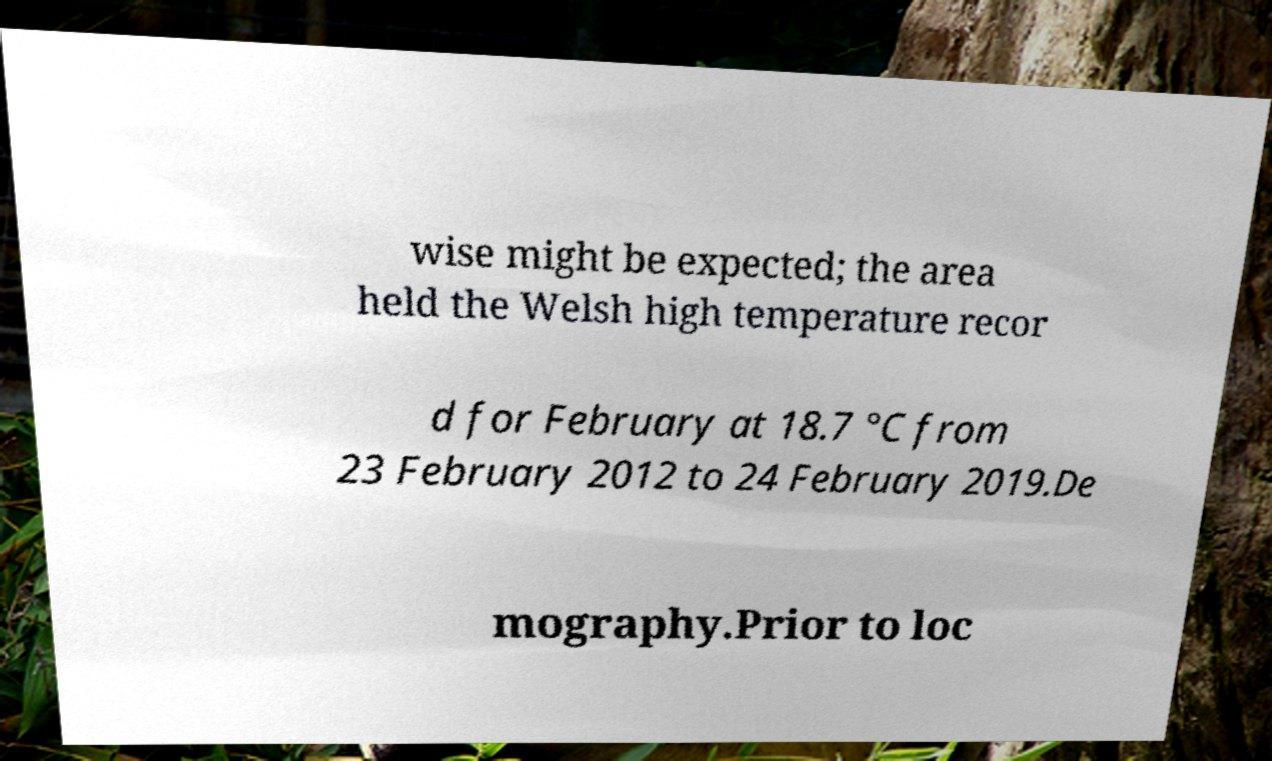For documentation purposes, I need the text within this image transcribed. Could you provide that? wise might be expected; the area held the Welsh high temperature recor d for February at 18.7 °C from 23 February 2012 to 24 February 2019.De mography.Prior to loc 